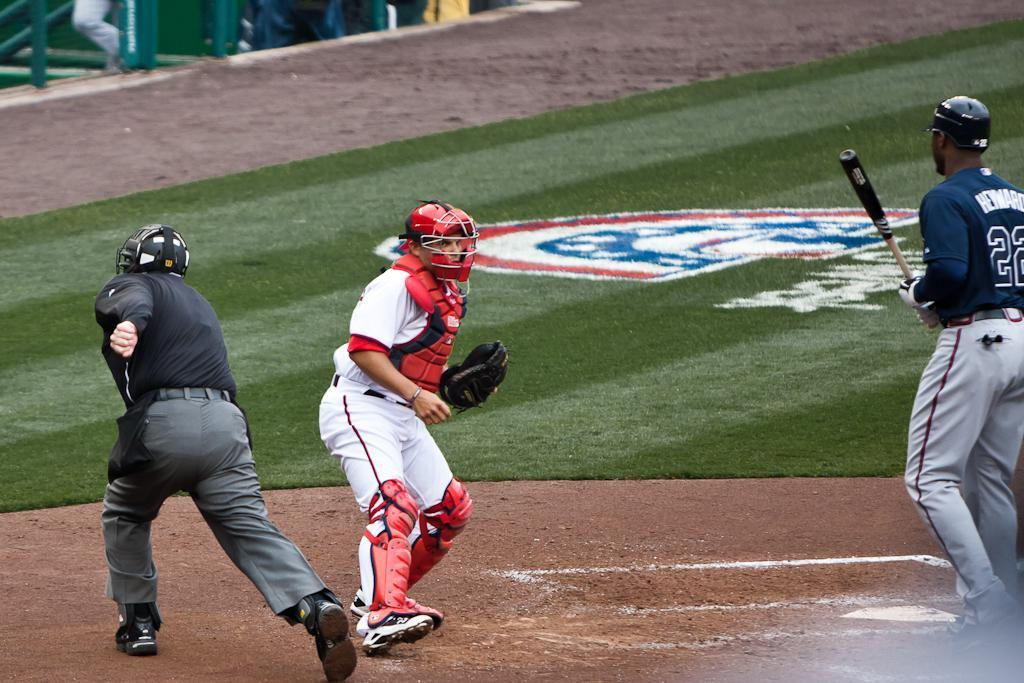<image>
Create a compact narrative representing the image presented. Baseball player in number 22 has the bat. 